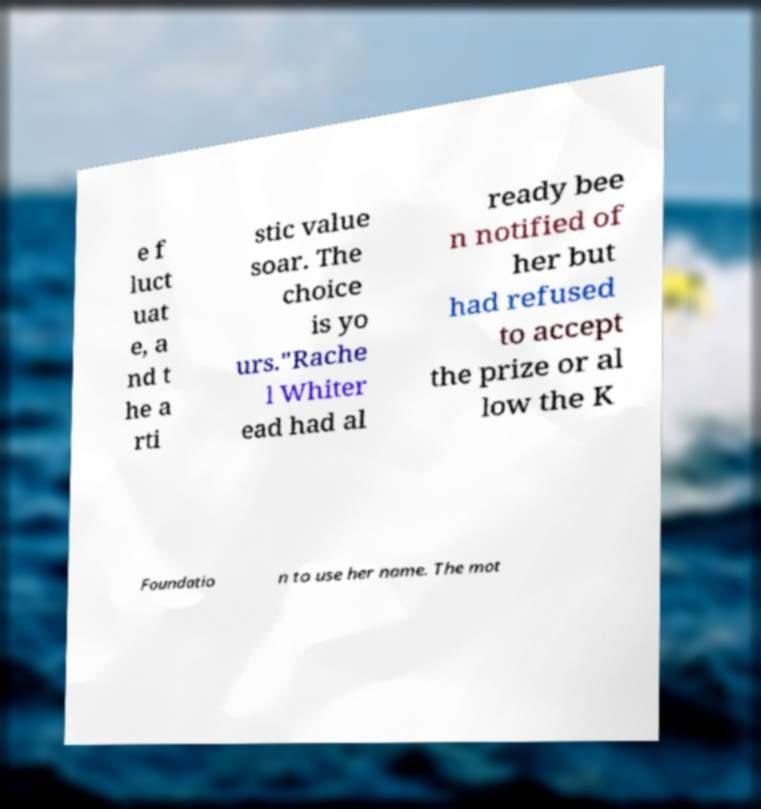Can you accurately transcribe the text from the provided image for me? e f luct uat e, a nd t he a rti stic value soar. The choice is yo urs."Rache l Whiter ead had al ready bee n notified of her but had refused to accept the prize or al low the K Foundatio n to use her name. The mot 